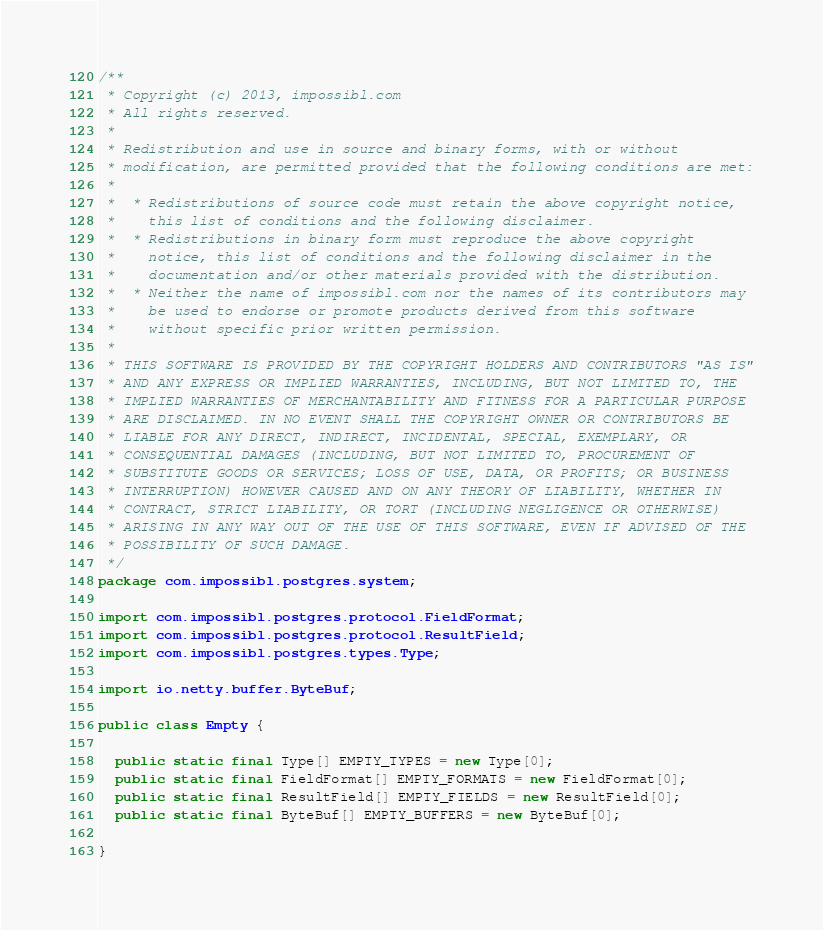Convert code to text. <code><loc_0><loc_0><loc_500><loc_500><_Java_>/**
 * Copyright (c) 2013, impossibl.com
 * All rights reserved.
 *
 * Redistribution and use in source and binary forms, with or without
 * modification, are permitted provided that the following conditions are met:
 *
 *  * Redistributions of source code must retain the above copyright notice,
 *    this list of conditions and the following disclaimer.
 *  * Redistributions in binary form must reproduce the above copyright
 *    notice, this list of conditions and the following disclaimer in the
 *    documentation and/or other materials provided with the distribution.
 *  * Neither the name of impossibl.com nor the names of its contributors may
 *    be used to endorse or promote products derived from this software
 *    without specific prior written permission.
 *
 * THIS SOFTWARE IS PROVIDED BY THE COPYRIGHT HOLDERS AND CONTRIBUTORS "AS IS"
 * AND ANY EXPRESS OR IMPLIED WARRANTIES, INCLUDING, BUT NOT LIMITED TO, THE
 * IMPLIED WARRANTIES OF MERCHANTABILITY AND FITNESS FOR A PARTICULAR PURPOSE
 * ARE DISCLAIMED. IN NO EVENT SHALL THE COPYRIGHT OWNER OR CONTRIBUTORS BE
 * LIABLE FOR ANY DIRECT, INDIRECT, INCIDENTAL, SPECIAL, EXEMPLARY, OR
 * CONSEQUENTIAL DAMAGES (INCLUDING, BUT NOT LIMITED TO, PROCUREMENT OF
 * SUBSTITUTE GOODS OR SERVICES; LOSS OF USE, DATA, OR PROFITS; OR BUSINESS
 * INTERRUPTION) HOWEVER CAUSED AND ON ANY THEORY OF LIABILITY, WHETHER IN
 * CONTRACT, STRICT LIABILITY, OR TORT (INCLUDING NEGLIGENCE OR OTHERWISE)
 * ARISING IN ANY WAY OUT OF THE USE OF THIS SOFTWARE, EVEN IF ADVISED OF THE
 * POSSIBILITY OF SUCH DAMAGE.
 */
package com.impossibl.postgres.system;

import com.impossibl.postgres.protocol.FieldFormat;
import com.impossibl.postgres.protocol.ResultField;
import com.impossibl.postgres.types.Type;

import io.netty.buffer.ByteBuf;

public class Empty {

  public static final Type[] EMPTY_TYPES = new Type[0];
  public static final FieldFormat[] EMPTY_FORMATS = new FieldFormat[0];
  public static final ResultField[] EMPTY_FIELDS = new ResultField[0];
  public static final ByteBuf[] EMPTY_BUFFERS = new ByteBuf[0];

}
</code> 